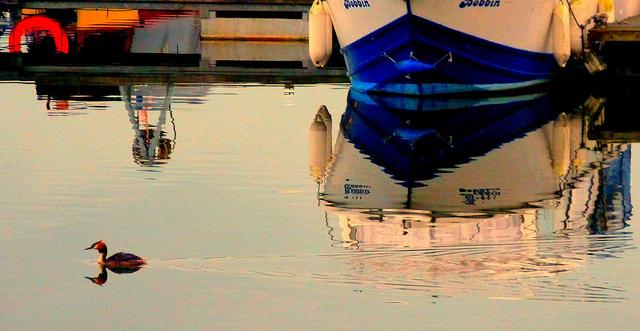What is the animal doing?
Concise answer only. Swimming. What animal is on the water?
Answer briefly. Duck. Is it sunny?
Concise answer only. Yes. 